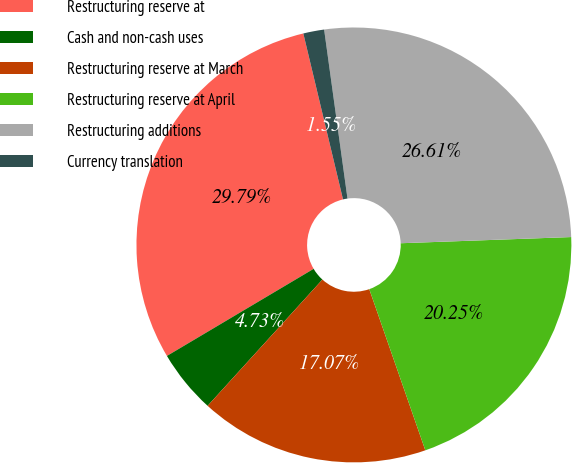Convert chart. <chart><loc_0><loc_0><loc_500><loc_500><pie_chart><fcel>Restructuring reserve at<fcel>Cash and non-cash uses<fcel>Restructuring reserve at March<fcel>Restructuring reserve at April<fcel>Restructuring additions<fcel>Currency translation<nl><fcel>29.79%<fcel>4.73%<fcel>17.07%<fcel>20.25%<fcel>26.61%<fcel>1.55%<nl></chart> 